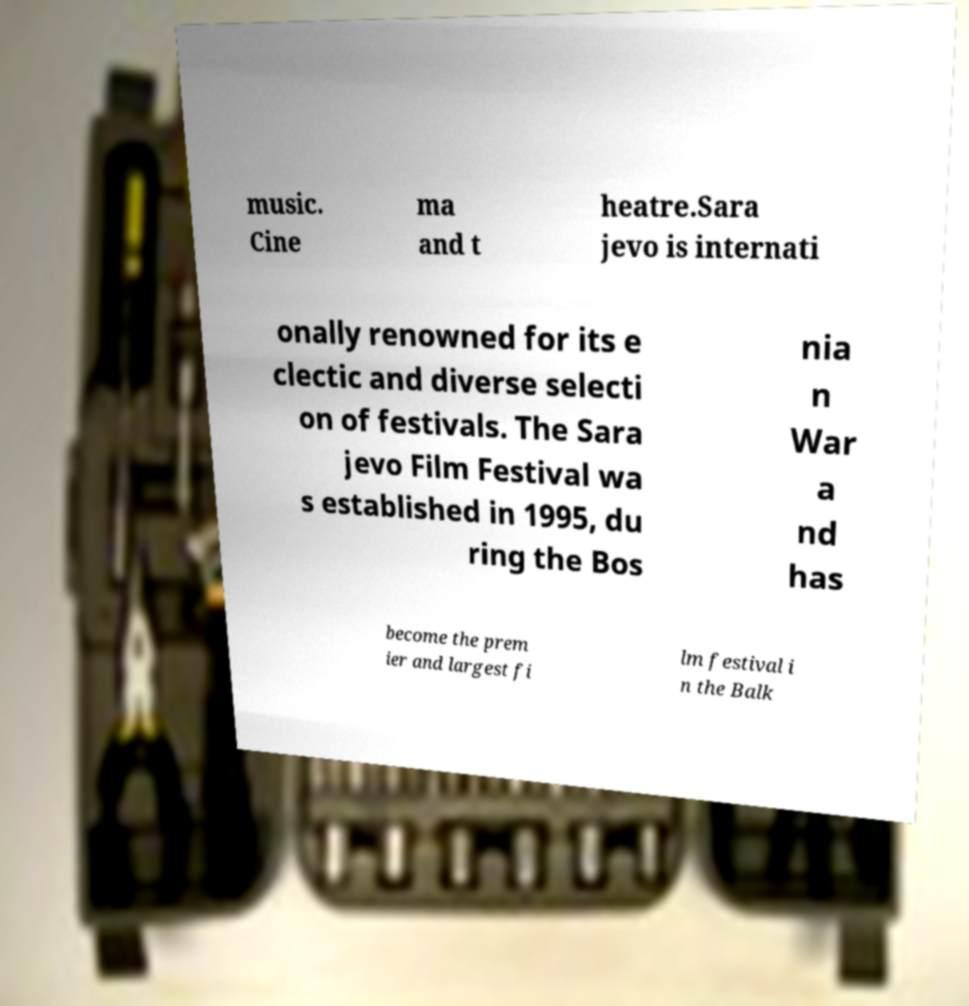For documentation purposes, I need the text within this image transcribed. Could you provide that? music. Cine ma and t heatre.Sara jevo is internati onally renowned for its e clectic and diverse selecti on of festivals. The Sara jevo Film Festival wa s established in 1995, du ring the Bos nia n War a nd has become the prem ier and largest fi lm festival i n the Balk 